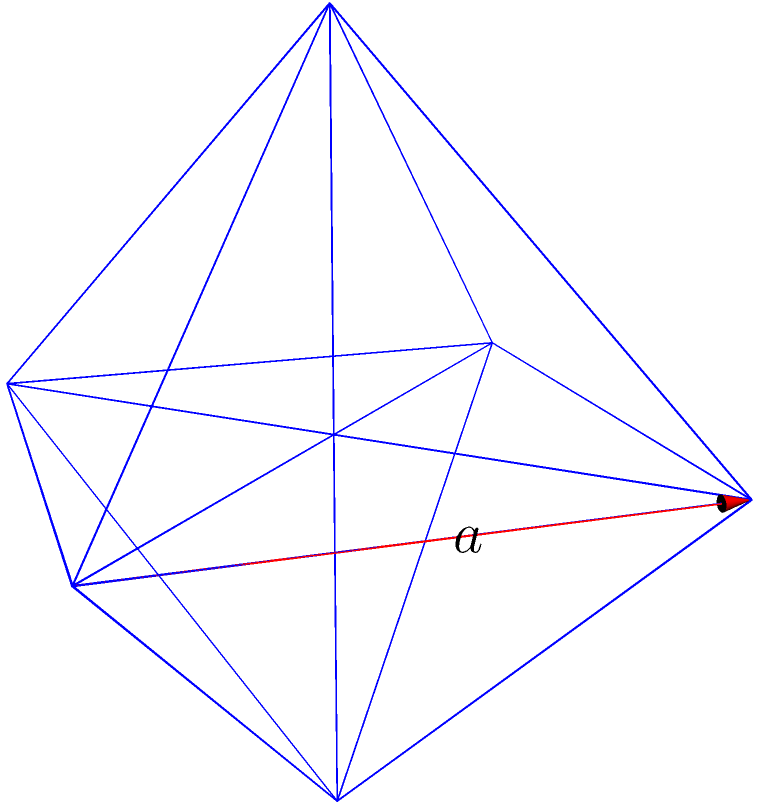As you contemplate the geometric precision in Saba Sams' storytelling, imagine an octahedron with edges as sharp as her narrative edges. If each edge of this regular octahedron measures $a$ units in length, what is its total surface area in terms of $a$? Let's approach this step-by-step, drawing inspiration from the structured yet creative process of writing:

1) First, recall that a regular octahedron consists of 8 equilateral triangular faces.

2) To find the surface area, we need to calculate the area of one triangular face and multiply it by 8.

3) For an equilateral triangle with side length $a$, the area is given by:

   $$A_{triangle} = \frac{\sqrt{3}}{4}a^2$$

4) This formula comes from the fact that the height of an equilateral triangle is $\frac{\sqrt{3}}{2}a$, and the area of a triangle is $\frac{1}{2} \times base \times height$.

5) Now, for the entire octahedron, we multiply this by 8:

   $$A_{octahedron} = 8 \times \frac{\sqrt{3}}{4}a^2 = 2\sqrt{3}a^2$$

6) Therefore, the total surface area of the octahedron is $2\sqrt{3}a^2$ square units.

Just as Saba Sams crafts her stories with precision and elegance, we've constructed this geometric solution, piece by piece, to reveal the beautiful symmetry of the octahedron.
Answer: $2\sqrt{3}a^2$ square units 